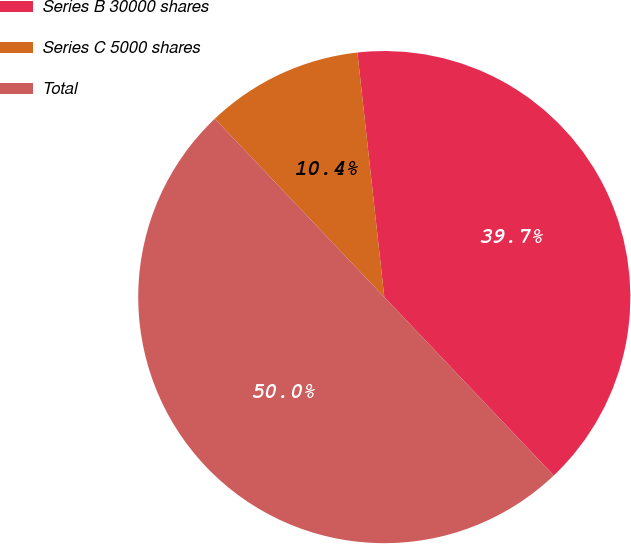<chart> <loc_0><loc_0><loc_500><loc_500><pie_chart><fcel>Series B 30000 shares<fcel>Series C 5000 shares<fcel>Total<nl><fcel>39.65%<fcel>10.35%<fcel>50.0%<nl></chart> 